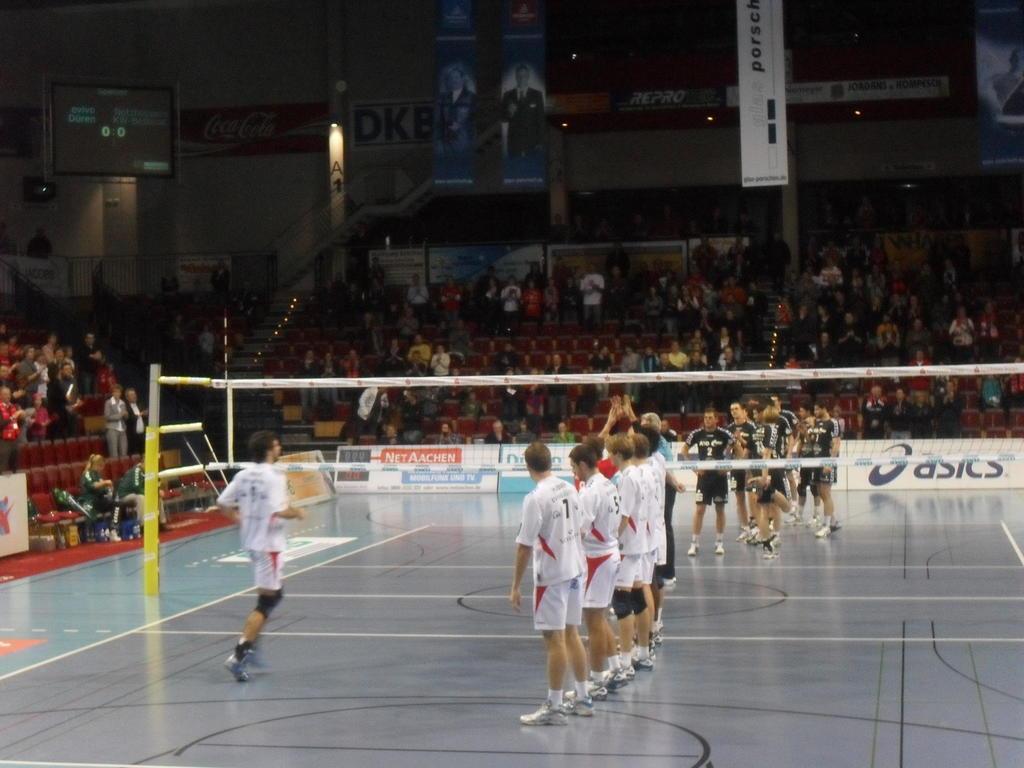Can you describe this image briefly? This picture looks like a stadium, in this image we can see a few people, among them, some are in sports wear, there are chairs, posters, boards with text, net and some other objects, also we can see a screen. 